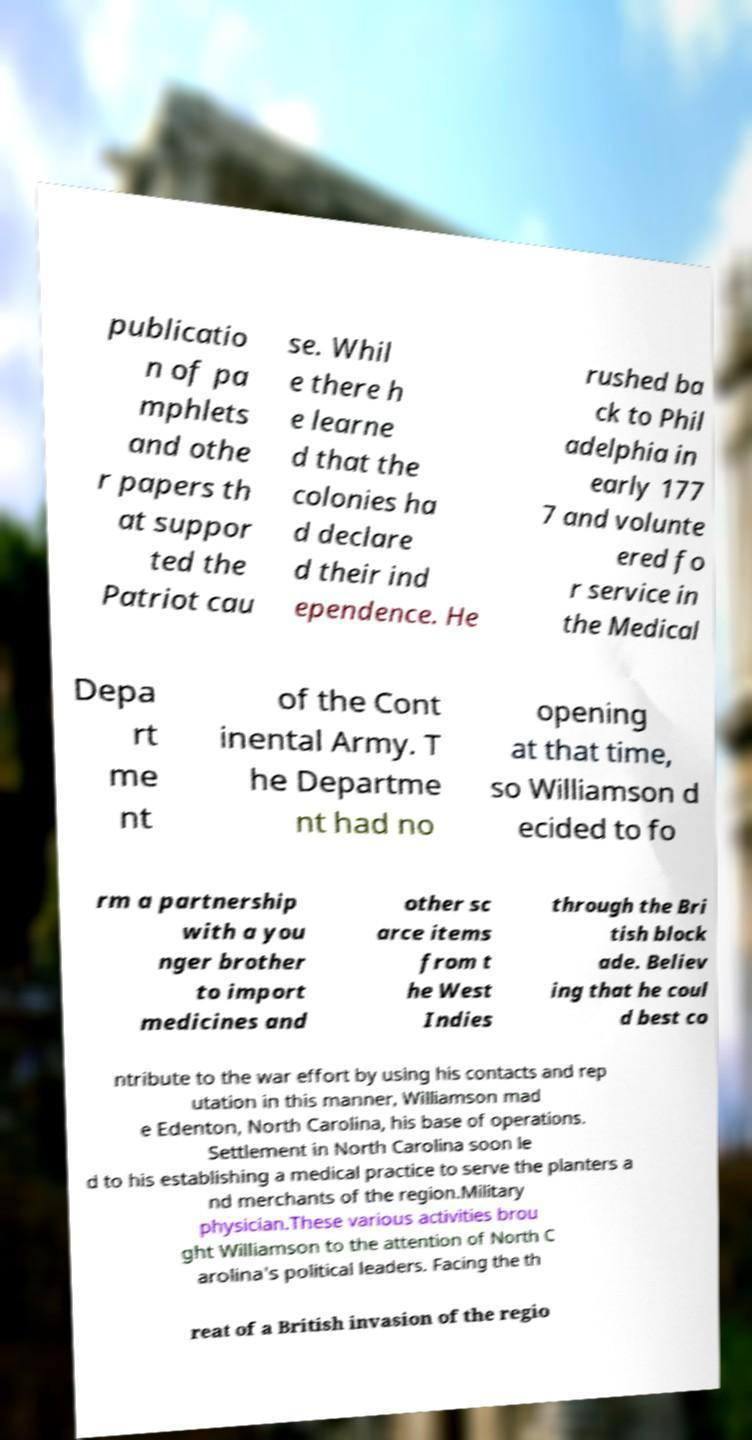Can you accurately transcribe the text from the provided image for me? publicatio n of pa mphlets and othe r papers th at suppor ted the Patriot cau se. Whil e there h e learne d that the colonies ha d declare d their ind ependence. He rushed ba ck to Phil adelphia in early 177 7 and volunte ered fo r service in the Medical Depa rt me nt of the Cont inental Army. T he Departme nt had no opening at that time, so Williamson d ecided to fo rm a partnership with a you nger brother to import medicines and other sc arce items from t he West Indies through the Bri tish block ade. Believ ing that he coul d best co ntribute to the war effort by using his contacts and rep utation in this manner, Williamson mad e Edenton, North Carolina, his base of operations. Settlement in North Carolina soon le d to his establishing a medical practice to serve the planters a nd merchants of the region.Military physician.These various activities brou ght Williamson to the attention of North C arolina's political leaders. Facing the th reat of a British invasion of the regio 